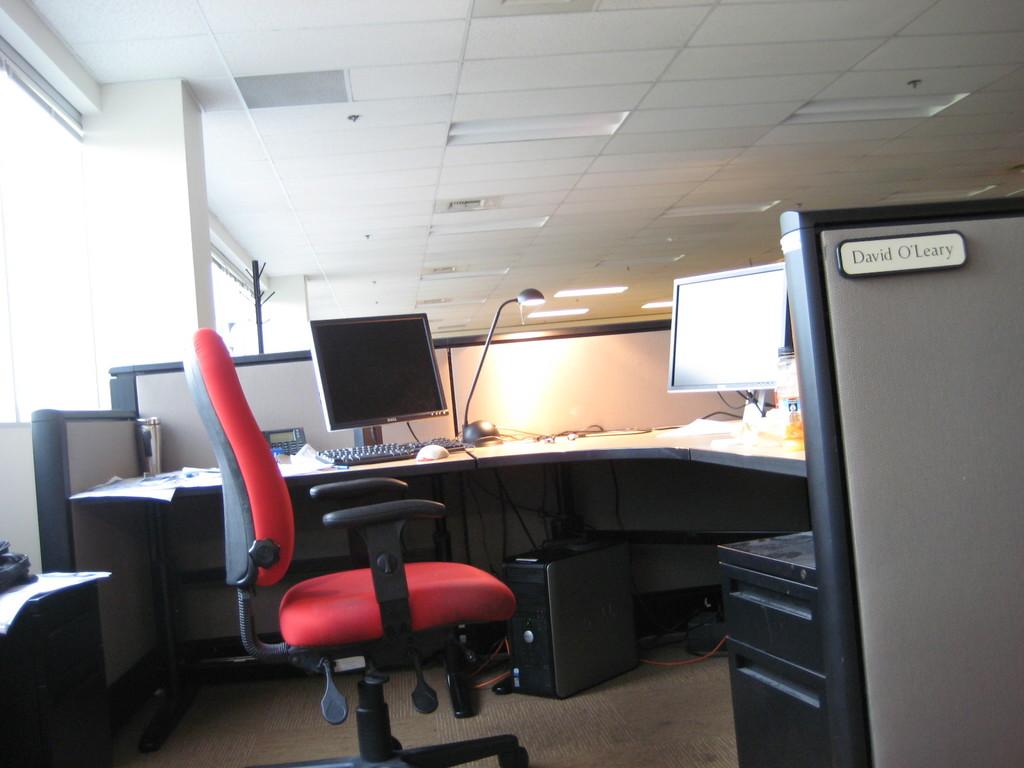Who does this cubicle belong too?
Offer a very short reply. David o'leary. 